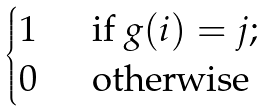Convert formula to latex. <formula><loc_0><loc_0><loc_500><loc_500>\begin{cases} 1 & \ \text { if } g ( i ) = j ; \\ 0 & \ \text { otherwise} \end{cases}</formula> 